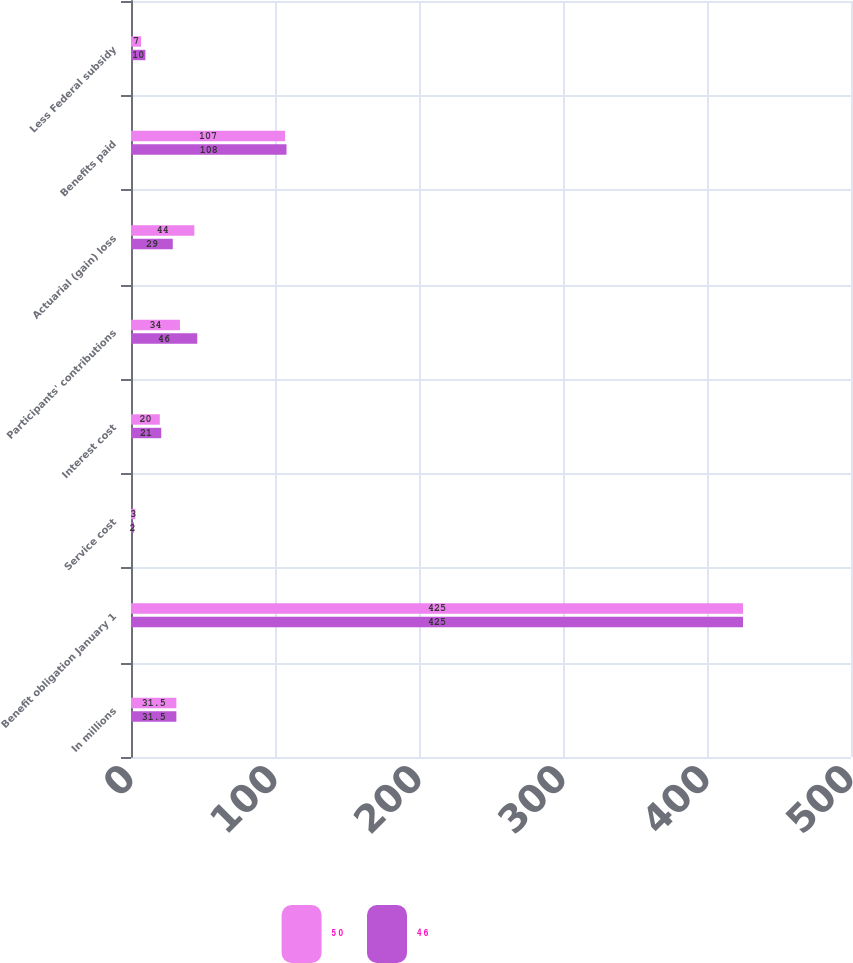Convert chart to OTSL. <chart><loc_0><loc_0><loc_500><loc_500><stacked_bar_chart><ecel><fcel>In millions<fcel>Benefit obligation January 1<fcel>Service cost<fcel>Interest cost<fcel>Participants' contributions<fcel>Actuarial (gain) loss<fcel>Benefits paid<fcel>Less Federal subsidy<nl><fcel>5 0<fcel>31.5<fcel>425<fcel>3<fcel>20<fcel>34<fcel>44<fcel>107<fcel>7<nl><fcel>4 6<fcel>31.5<fcel>425<fcel>2<fcel>21<fcel>46<fcel>29<fcel>108<fcel>10<nl></chart> 